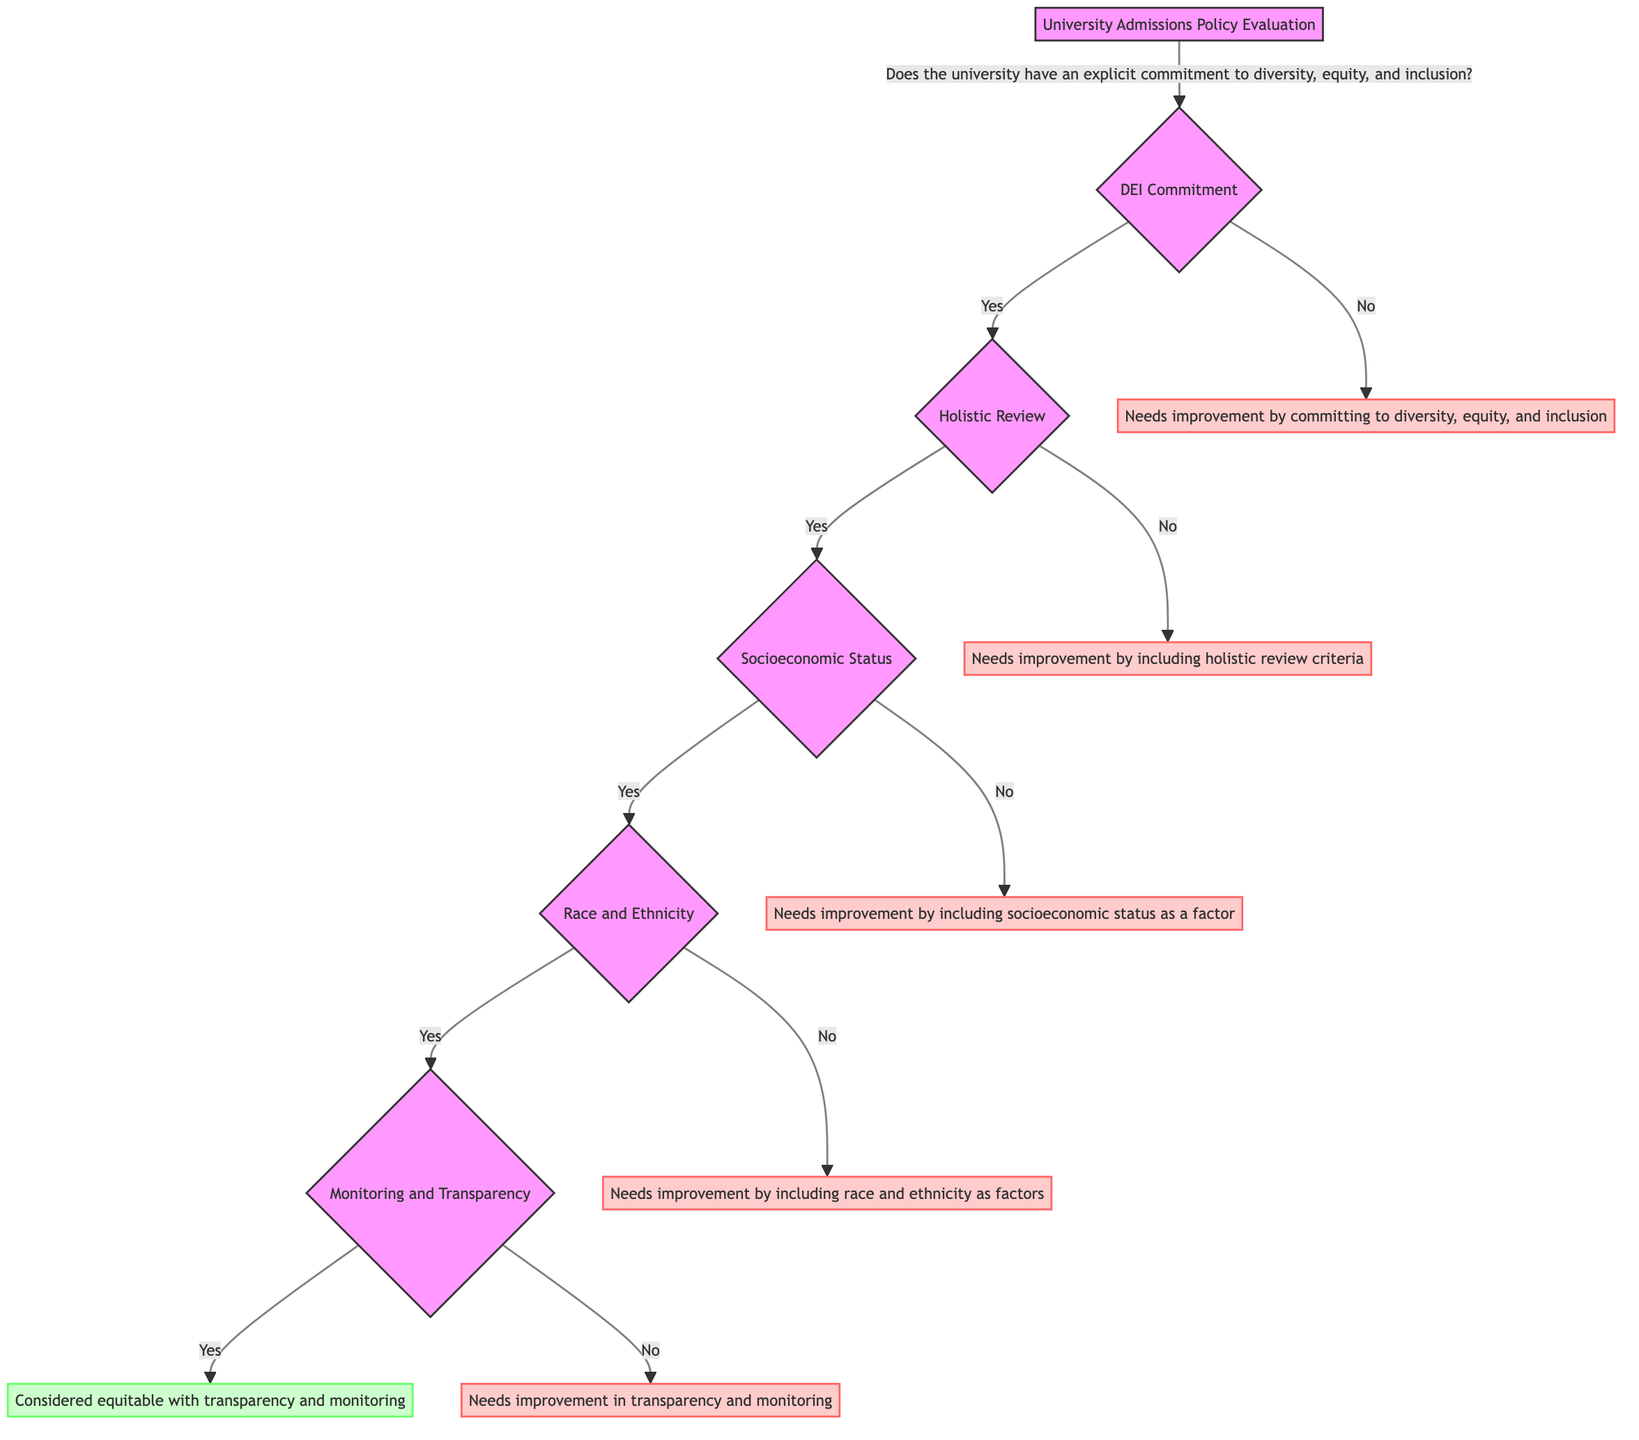Does the university have an explicit commitment to diversity, equity, and inclusion? This is the first question presented at the root of the decision tree and directly asks about the university's commitment to DEI. The answer can be "Yes" or "No," leading to different subsequent questions or conclusions based on the response.
Answer: Yes/No What does the answer "Yes" lead to next? Following a "Yes" answer to the commitment question, the next question is about whether the admissions policy includes holistic review criteria. This shows that universities that have a commitment are evaluated on further criteria.
Answer: Holistic Review How many criteria are evaluated after the commitment question? After the initial commitment question, there are three main criteria evaluated: whether holistic review criteria are included, whether socioeconomic status is considered, and whether race and ethnicity are considered if socioeconomic status is included. The flow branches at various nodes each representing a different facet of the policy.
Answer: Three What happens if the admissions policy does not include holistic review criteria? If the admissions policy does not include holistic review criteria, the conclusion states that it "Needs improvement by including holistic review criteria." This highlights the importance of this aspect in achieving equity and inclusion.
Answer: Needs improvement by including holistic review criteria If a university considers socioeconomic status, what is the next question asked? After confirming that the admissions policy includes socioeconomic status, the next question assesses whether the policy also considers race and ethnicity. This indicates a layered evaluation of admissions frameworks.
Answer: Race and Ethnicity What is the outcome if a university includes race and ethnicity as factors and has monitoring? If a university includes race and ethnicity as factors and has monitoring and transparency of admissions data, the outcome indicates that the university is "Considered equitable with transparency and monitoring." This shows a positive evaluation of the university's admissions policy.
Answer: Considered equitable with transparency and monitoring What does the flow indicate if no socioeconomic status is considered? If the admissions policy does not consider socioeconomic status, it leads to an improvement recommendation stating "Needs improvement by including socioeconomic status as a factor." This reveals a gap in addressing socioeconomic diversity in the admissions process.
Answer: Needs improvement by including socioeconomic status as a factor What type of improvements are suggested if the university has no commitment to DEI? The diagram specifies that if the university has no explicit commitment to diversity, equity, and inclusion, it "Needs improvement by committing to diversity, equity, and inclusion." This emphasizes the foundational role of DEI commitment in admissions policies.
Answer: Needs improvement by committing to diversity, equity, and inclusion 